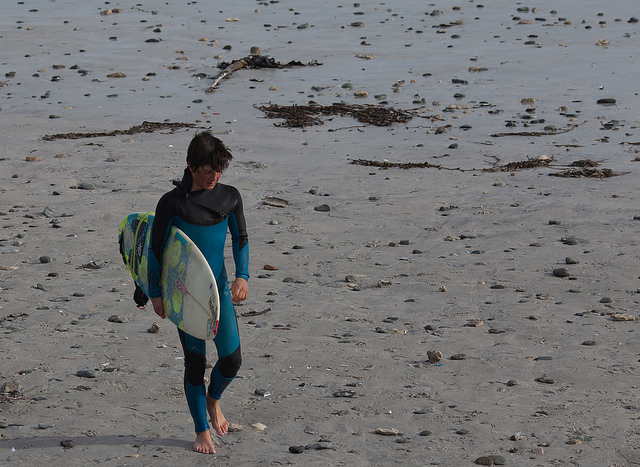<image>What does the surfboard say? I am not sure what the surfboard says. It could be 'free', 'love', 'kw', 'peace' or 'words'. What does the surfboard say? I am not sure what the surfboard says. It can be either 'free', 'peace', 'love' or 'words'. 